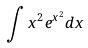Convert formula to latex. <formula><loc_0><loc_0><loc_500><loc_500>\int x ^ { 2 } e ^ { x ^ { 2 } } d x</formula> 